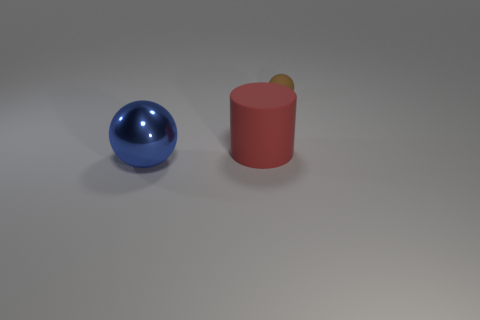Is there anything else that has the same size as the brown matte sphere?
Provide a succinct answer. No. Are there any other things that are made of the same material as the blue object?
Make the answer very short. No. What number of other objects are there of the same size as the brown object?
Offer a very short reply. 0. Is the color of the large rubber thing the same as the metal ball?
Offer a terse response. No. There is a large object that is on the right side of the metallic ball left of the big thing that is behind the big blue object; what shape is it?
Your answer should be very brief. Cylinder. What number of things are either objects that are behind the big red object or objects in front of the matte sphere?
Your response must be concise. 3. What size is the thing that is in front of the matte thing in front of the tiny brown sphere?
Make the answer very short. Large. Is there a large blue metal object that has the same shape as the tiny object?
Give a very brief answer. Yes. The matte cylinder that is the same size as the metal sphere is what color?
Your answer should be very brief. Red. What is the size of the sphere in front of the brown object?
Keep it short and to the point. Large. 